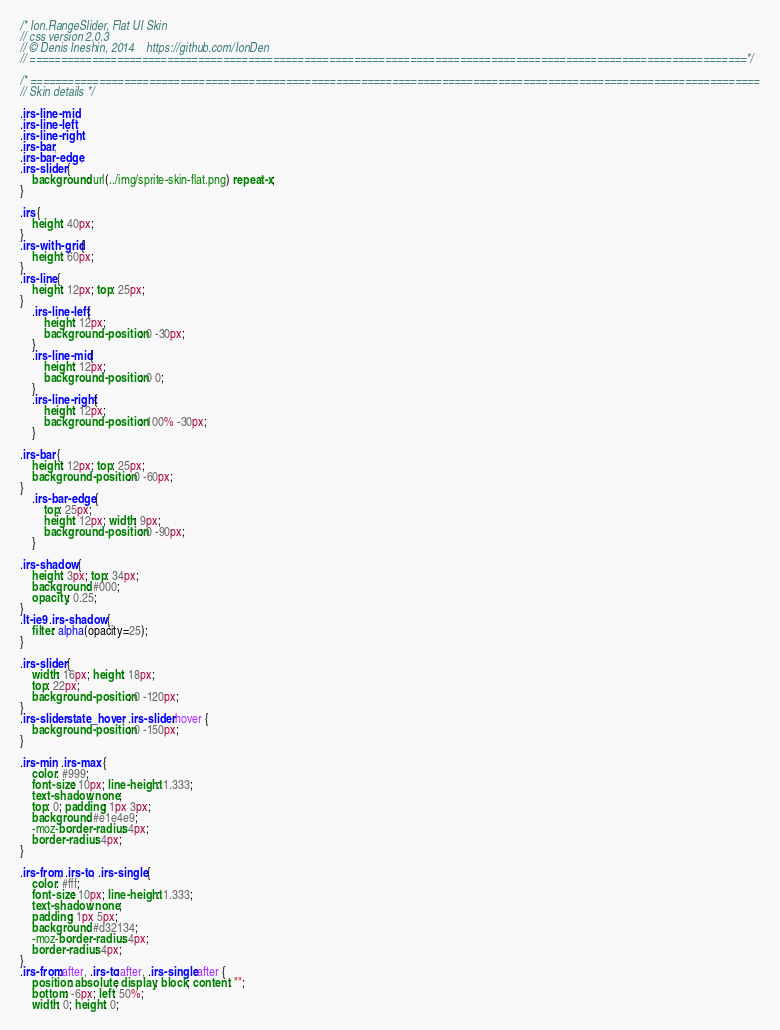Convert code to text. <code><loc_0><loc_0><loc_500><loc_500><_CSS_>/* Ion.RangeSlider, Flat UI Skin
// css version 2.0.3
// © Denis Ineshin, 2014    https://github.com/IonDen
// ===================================================================================================================*/

/* =====================================================================================================================
// Skin details */

.irs-line-mid,
.irs-line-left,
.irs-line-right,
.irs-bar,
.irs-bar-edge,
.irs-slider {
    background: url(../img/sprite-skin-flat.png) repeat-x;
}

.irs {
    height: 40px;
}
.irs-with-grid {
    height: 60px;
}
.irs-line {
    height: 12px; top: 25px;
}
    .irs-line-left {
        height: 12px;
        background-position: 0 -30px;
    }
    .irs-line-mid {
        height: 12px;
        background-position: 0 0;
    }
    .irs-line-right {
        height: 12px;
        background-position: 100% -30px;
    }

.irs-bar {
    height: 12px; top: 25px;
    background-position: 0 -60px;
}
    .irs-bar-edge {
        top: 25px;
        height: 12px; width: 9px;
        background-position: 0 -90px;
    }

.irs-shadow {
    height: 3px; top: 34px;
    background: #000;
    opacity: 0.25;
}
.lt-ie9 .irs-shadow {
    filter: alpha(opacity=25);
}

.irs-slider {
    width: 16px; height: 18px;
    top: 22px;
    background-position: 0 -120px;
}
.irs-slider.state_hover, .irs-slider:hover {
    background-position: 0 -150px;
}

.irs-min, .irs-max {
    color: #999;
    font-size: 10px; line-height: 1.333;
    text-shadow: none;
    top: 0; padding: 1px 3px;
    background: #e1e4e9;
    -moz-border-radius: 4px;
    border-radius: 4px;
}

.irs-from, .irs-to, .irs-single {
    color: #fff;
    font-size: 10px; line-height: 1.333;
    text-shadow: none;
    padding: 1px 5px;
    background: #d32134;
    -moz-border-radius: 4px;
    border-radius: 4px;
}
.irs-from:after, .irs-to:after, .irs-single:after {
    position: absolute; display: block; content: "";
    bottom: -6px; left: 50%;
    width: 0; height: 0;</code> 